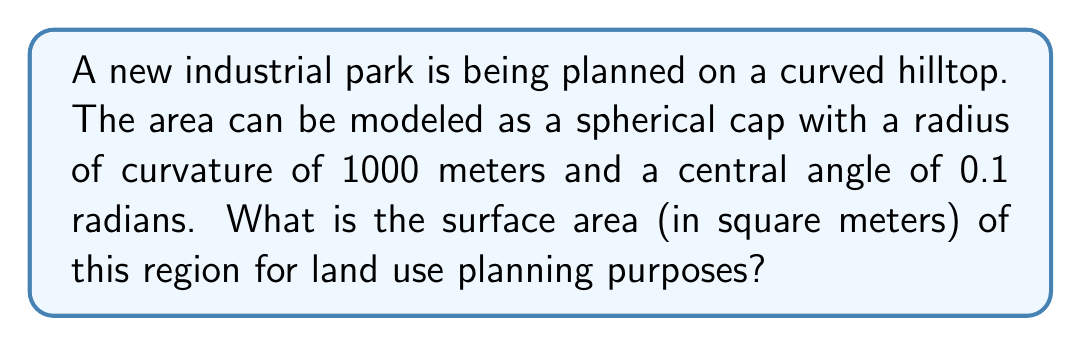Provide a solution to this math problem. To solve this problem, we'll use the formula for the surface area of a spherical cap:

$$A = 2\pi R h$$

Where:
$A$ is the surface area
$R$ is the radius of the sphere
$h$ is the height of the cap

Step 1: Calculate the height of the cap using the central angle $\theta$:
$$h = R(1 - \cos(\theta/2))$$
$$h = 1000(1 - \cos(0.1/2))$$
$$h = 1000(1 - \cos(0.05))$$
$$h \approx 1.25 \text{ meters}$$

Step 2: Apply the surface area formula:
$$A = 2\pi R h$$
$$A = 2\pi(1000)(1.25)$$
$$A = 2500\pi$$
$$A \approx 7853.98 \text{ square meters}$$

This calculation provides the surface area of the curved region, which is larger than the area would be if projected onto a flat plane. This is crucial for accurate land use planning in non-flat terrains.
Answer: 7853.98 square meters 